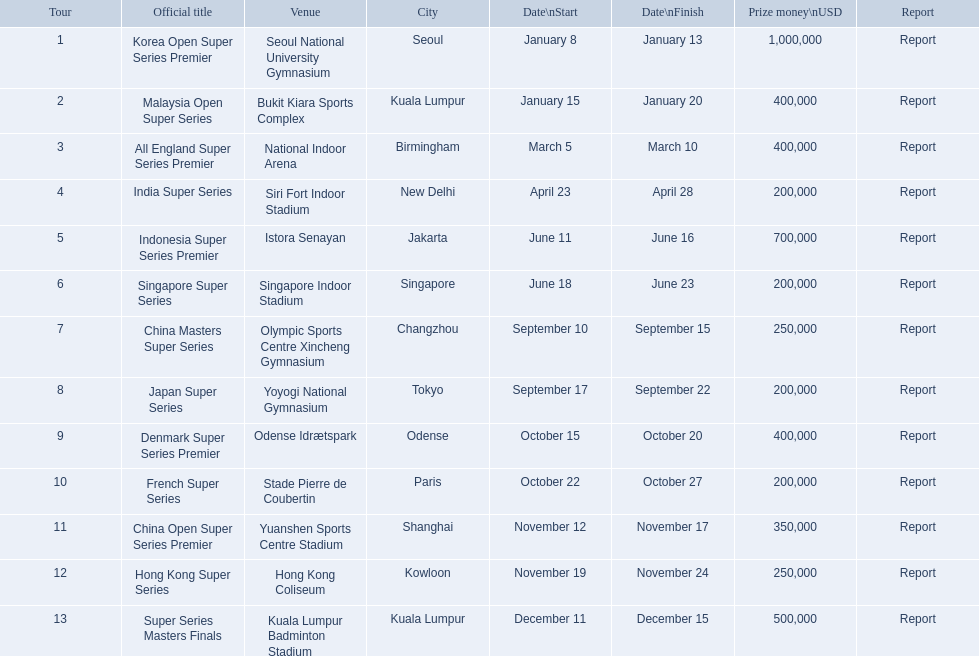What were the titles of the 2013 bwf super series? Korea Open Super Series Premier, Malaysia Open Super Series, All England Super Series Premier, India Super Series, Indonesia Super Series Premier, Singapore Super Series, China Masters Super Series, Japan Super Series, Denmark Super Series Premier, French Super Series, China Open Super Series Premier, Hong Kong Super Series, Super Series Masters Finals. Which were in december? Super Series Masters Finals. What are all the tours? Korea Open Super Series Premier, Malaysia Open Super Series, All England Super Series Premier, India Super Series, Indonesia Super Series Premier, Singapore Super Series, China Masters Super Series, Japan Super Series, Denmark Super Series Premier, French Super Series, China Open Super Series Premier, Hong Kong Super Series, Super Series Masters Finals. What were the start dates of these tours? January 8, January 15, March 5, April 23, June 11, June 18, September 10, September 17, October 15, October 22, November 12, November 19, December 11. Of these, which is in december? December 11. Which tour started on this date? Super Series Masters Finals. 